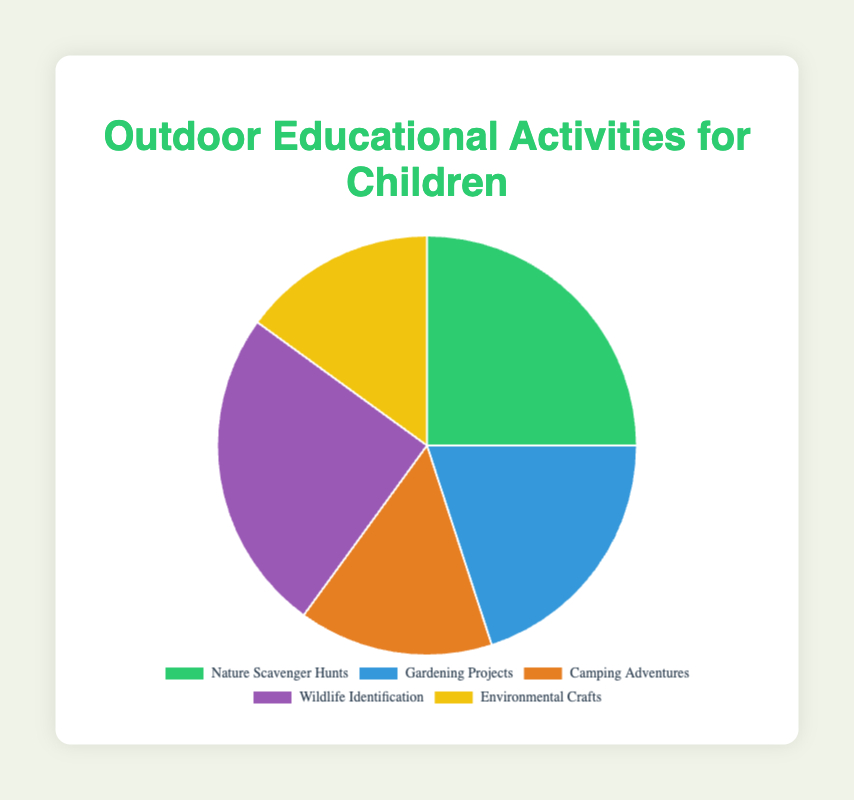Which two activities have the highest percentage of participation? Nature Scavenger Hunts and Wildlife Identification both have 25%. They are the highest because no other activities have more than 25%.
Answer: Nature Scavenger Hunts and Wildlife Identification What is the combined percentage of Gardening Projects and Environmental Crafts? The percentage of Gardening Projects is 20% and Environmental Crafts is 15%. Adding these gives 20% + 15% = 35%.
Answer: 35% How much more popular are Nature Scavenger Hunts than Camping Adventures? Nature Scavenger Hunts have 25%, and Camping Adventures have 15%. The difference is 25% - 15% = 10%.
Answer: 10% Which activities have the exact same percentage of participation? Nature Scavenger Hunts and Wildlife Identification both have 25%, and Camping Adventures and Environmental Crafts both have 15%.
Answer: Nature Scavenger Hunts and Wildlife Identification; Camping Adventures and Environmental Crafts What is the average percentage of all the activities? The percentages are 25%, 20%, 15%, 25%, and 15%. Adding these gives 25 + 20 + 15 + 25 + 15 = 100. There are 5 activities, so the average is 100/5 = 20%.
Answer: 20% Out of all activities, which one is depicted in blue (Gardening Projects) and what is its percentage? By referring to the color coding, Gardening Projects are depicted in blue and have a percentage of 20%.
Answer: 20% What is the total percentage of the activities that have less than 20% participation? The activities under 20% are Camping Adventures (15%) and Environmental Crafts (15%). Adding these gives 15% + 15% = 30%.
Answer: 30% Which activity has the lowest percentage, and how much is it? Both Camping Adventures and Environmental Crafts have the lowest percentage, which is 15%.
Answer: Camping Adventures and Environmental Crafts, 15% 